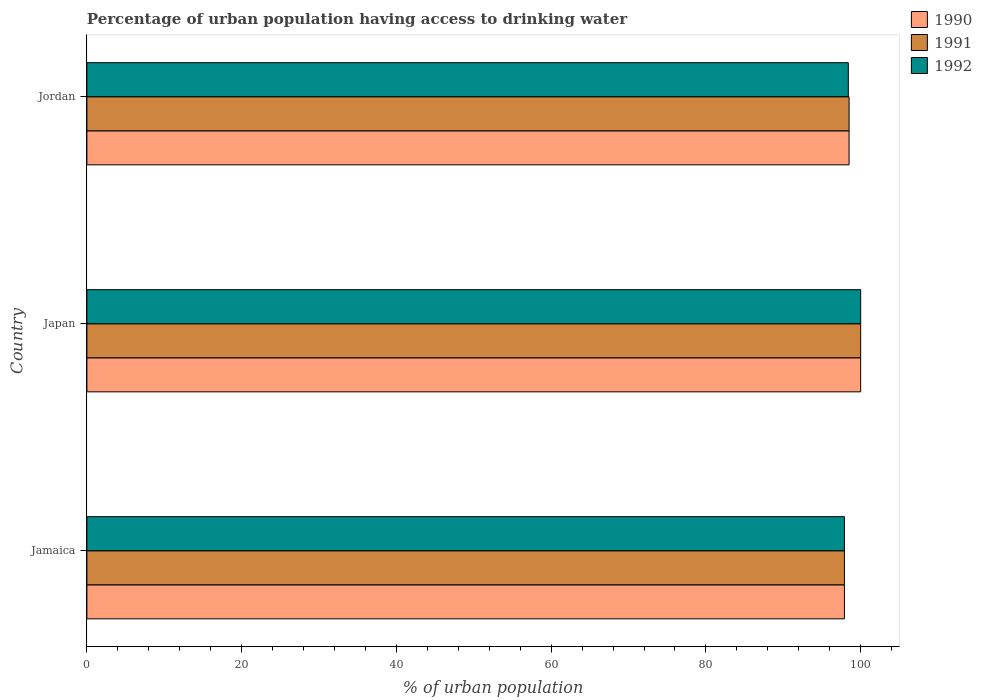How many bars are there on the 2nd tick from the top?
Provide a succinct answer. 3. How many bars are there on the 1st tick from the bottom?
Make the answer very short. 3. What is the label of the 3rd group of bars from the top?
Ensure brevity in your answer.  Jamaica. In how many cases, is the number of bars for a given country not equal to the number of legend labels?
Your answer should be very brief. 0. What is the percentage of urban population having access to drinking water in 1991 in Jordan?
Offer a very short reply. 98.5. Across all countries, what is the maximum percentage of urban population having access to drinking water in 1992?
Provide a short and direct response. 100. Across all countries, what is the minimum percentage of urban population having access to drinking water in 1991?
Ensure brevity in your answer.  97.9. In which country was the percentage of urban population having access to drinking water in 1990 minimum?
Your answer should be very brief. Jamaica. What is the total percentage of urban population having access to drinking water in 1992 in the graph?
Offer a terse response. 296.3. What is the difference between the percentage of urban population having access to drinking water in 1992 in Jamaica and that in Japan?
Make the answer very short. -2.1. What is the average percentage of urban population having access to drinking water in 1991 per country?
Keep it short and to the point. 98.8. What is the ratio of the percentage of urban population having access to drinking water in 1991 in Jamaica to that in Jordan?
Ensure brevity in your answer.  0.99. Is the difference between the percentage of urban population having access to drinking water in 1991 in Jamaica and Japan greater than the difference between the percentage of urban population having access to drinking water in 1990 in Jamaica and Japan?
Ensure brevity in your answer.  No. What is the difference between the highest and the lowest percentage of urban population having access to drinking water in 1990?
Your response must be concise. 2.1. In how many countries, is the percentage of urban population having access to drinking water in 1991 greater than the average percentage of urban population having access to drinking water in 1991 taken over all countries?
Make the answer very short. 1. Is it the case that in every country, the sum of the percentage of urban population having access to drinking water in 1991 and percentage of urban population having access to drinking water in 1990 is greater than the percentage of urban population having access to drinking water in 1992?
Offer a very short reply. Yes. Are all the bars in the graph horizontal?
Keep it short and to the point. Yes. How many countries are there in the graph?
Offer a very short reply. 3. What is the difference between two consecutive major ticks on the X-axis?
Your response must be concise. 20. Are the values on the major ticks of X-axis written in scientific E-notation?
Provide a short and direct response. No. Does the graph contain grids?
Your answer should be compact. No. Where does the legend appear in the graph?
Provide a short and direct response. Top right. How many legend labels are there?
Offer a terse response. 3. How are the legend labels stacked?
Offer a terse response. Vertical. What is the title of the graph?
Your answer should be compact. Percentage of urban population having access to drinking water. What is the label or title of the X-axis?
Keep it short and to the point. % of urban population. What is the % of urban population in 1990 in Jamaica?
Your response must be concise. 97.9. What is the % of urban population of 1991 in Jamaica?
Provide a succinct answer. 97.9. What is the % of urban population of 1992 in Jamaica?
Your answer should be very brief. 97.9. What is the % of urban population of 1990 in Japan?
Your response must be concise. 100. What is the % of urban population of 1991 in Japan?
Provide a succinct answer. 100. What is the % of urban population in 1990 in Jordan?
Make the answer very short. 98.5. What is the % of urban population of 1991 in Jordan?
Keep it short and to the point. 98.5. What is the % of urban population of 1992 in Jordan?
Your answer should be very brief. 98.4. Across all countries, what is the maximum % of urban population in 1990?
Provide a short and direct response. 100. Across all countries, what is the maximum % of urban population of 1991?
Provide a succinct answer. 100. Across all countries, what is the minimum % of urban population of 1990?
Your answer should be very brief. 97.9. Across all countries, what is the minimum % of urban population of 1991?
Make the answer very short. 97.9. Across all countries, what is the minimum % of urban population in 1992?
Your answer should be compact. 97.9. What is the total % of urban population of 1990 in the graph?
Keep it short and to the point. 296.4. What is the total % of urban population in 1991 in the graph?
Your response must be concise. 296.4. What is the total % of urban population in 1992 in the graph?
Provide a short and direct response. 296.3. What is the difference between the % of urban population in 1990 in Jamaica and that in Japan?
Keep it short and to the point. -2.1. What is the difference between the % of urban population in 1992 in Jamaica and that in Japan?
Provide a succinct answer. -2.1. What is the difference between the % of urban population in 1991 in Jamaica and that in Jordan?
Your answer should be compact. -0.6. What is the difference between the % of urban population of 1991 in Japan and that in Jordan?
Your answer should be very brief. 1.5. What is the difference between the % of urban population in 1992 in Japan and that in Jordan?
Your answer should be compact. 1.6. What is the difference between the % of urban population of 1990 in Jamaica and the % of urban population of 1991 in Japan?
Keep it short and to the point. -2.1. What is the difference between the % of urban population in 1990 in Jamaica and the % of urban population in 1992 in Japan?
Make the answer very short. -2.1. What is the difference between the % of urban population of 1990 in Jamaica and the % of urban population of 1991 in Jordan?
Your answer should be compact. -0.6. What is the difference between the % of urban population in 1990 in Japan and the % of urban population in 1992 in Jordan?
Your answer should be very brief. 1.6. What is the difference between the % of urban population in 1991 in Japan and the % of urban population in 1992 in Jordan?
Ensure brevity in your answer.  1.6. What is the average % of urban population in 1990 per country?
Your answer should be compact. 98.8. What is the average % of urban population in 1991 per country?
Make the answer very short. 98.8. What is the average % of urban population in 1992 per country?
Your answer should be very brief. 98.77. What is the difference between the % of urban population in 1991 and % of urban population in 1992 in Jamaica?
Your response must be concise. 0. What is the difference between the % of urban population in 1990 and % of urban population in 1991 in Japan?
Keep it short and to the point. 0. What is the difference between the % of urban population in 1990 and % of urban population in 1992 in Jordan?
Ensure brevity in your answer.  0.1. What is the ratio of the % of urban population in 1991 in Jamaica to that in Japan?
Your answer should be compact. 0.98. What is the ratio of the % of urban population of 1992 in Jamaica to that in Japan?
Provide a short and direct response. 0.98. What is the ratio of the % of urban population of 1990 in Jamaica to that in Jordan?
Make the answer very short. 0.99. What is the ratio of the % of urban population in 1992 in Jamaica to that in Jordan?
Offer a very short reply. 0.99. What is the ratio of the % of urban population in 1990 in Japan to that in Jordan?
Offer a terse response. 1.02. What is the ratio of the % of urban population in 1991 in Japan to that in Jordan?
Your response must be concise. 1.02. What is the ratio of the % of urban population in 1992 in Japan to that in Jordan?
Your response must be concise. 1.02. What is the difference between the highest and the second highest % of urban population of 1990?
Offer a terse response. 1.5. 